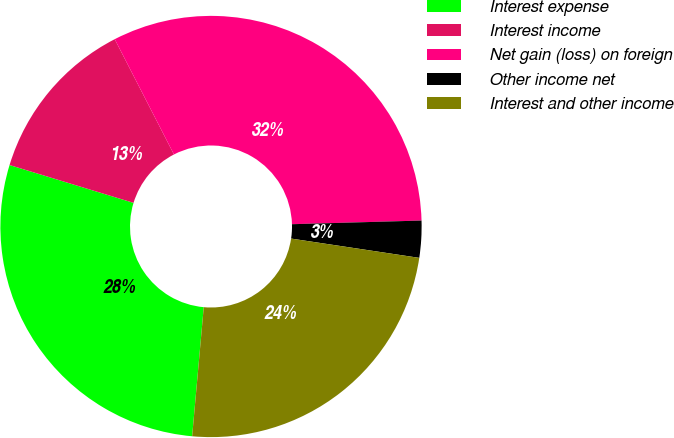Convert chart. <chart><loc_0><loc_0><loc_500><loc_500><pie_chart><fcel>Interest expense<fcel>Interest income<fcel>Net gain (loss) on foreign<fcel>Other income net<fcel>Interest and other income<nl><fcel>28.29%<fcel>12.73%<fcel>32.11%<fcel>2.83%<fcel>24.05%<nl></chart> 